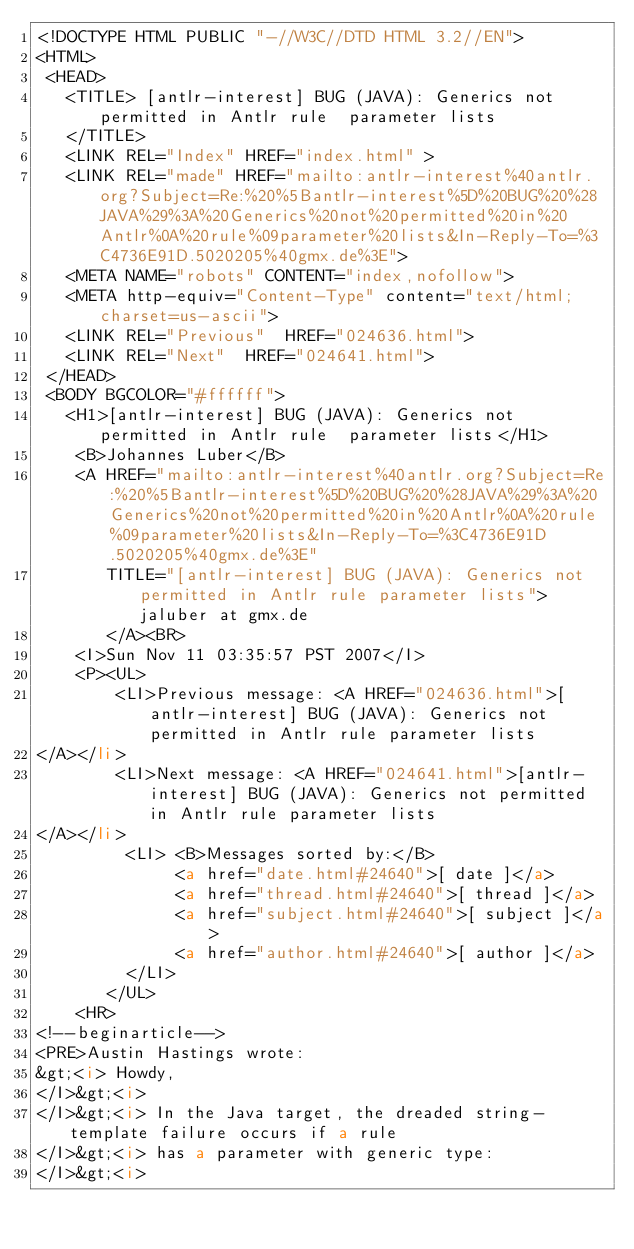<code> <loc_0><loc_0><loc_500><loc_500><_HTML_><!DOCTYPE HTML PUBLIC "-//W3C//DTD HTML 3.2//EN">
<HTML>
 <HEAD>
   <TITLE> [antlr-interest] BUG (JAVA): Generics not permitted in Antlr rule	parameter lists
   </TITLE>
   <LINK REL="Index" HREF="index.html" >
   <LINK REL="made" HREF="mailto:antlr-interest%40antlr.org?Subject=Re:%20%5Bantlr-interest%5D%20BUG%20%28JAVA%29%3A%20Generics%20not%20permitted%20in%20Antlr%0A%20rule%09parameter%20lists&In-Reply-To=%3C4736E91D.5020205%40gmx.de%3E">
   <META NAME="robots" CONTENT="index,nofollow">
   <META http-equiv="Content-Type" content="text/html; charset=us-ascii">
   <LINK REL="Previous"  HREF="024636.html">
   <LINK REL="Next"  HREF="024641.html">
 </HEAD>
 <BODY BGCOLOR="#ffffff">
   <H1>[antlr-interest] BUG (JAVA): Generics not permitted in Antlr rule	parameter lists</H1>
    <B>Johannes Luber</B> 
    <A HREF="mailto:antlr-interest%40antlr.org?Subject=Re:%20%5Bantlr-interest%5D%20BUG%20%28JAVA%29%3A%20Generics%20not%20permitted%20in%20Antlr%0A%20rule%09parameter%20lists&In-Reply-To=%3C4736E91D.5020205%40gmx.de%3E"
       TITLE="[antlr-interest] BUG (JAVA): Generics not permitted in Antlr rule	parameter lists">jaluber at gmx.de
       </A><BR>
    <I>Sun Nov 11 03:35:57 PST 2007</I>
    <P><UL>
        <LI>Previous message: <A HREF="024636.html">[antlr-interest] BUG (JAVA): Generics not permitted in Antlr rule	parameter lists
</A></li>
        <LI>Next message: <A HREF="024641.html">[antlr-interest] BUG (JAVA): Generics not permitted in Antlr rule	parameter lists
</A></li>
         <LI> <B>Messages sorted by:</B> 
              <a href="date.html#24640">[ date ]</a>
              <a href="thread.html#24640">[ thread ]</a>
              <a href="subject.html#24640">[ subject ]</a>
              <a href="author.html#24640">[ author ]</a>
         </LI>
       </UL>
    <HR>  
<!--beginarticle-->
<PRE>Austin Hastings wrote:
&gt;<i> Howdy,
</I>&gt;<i> 
</I>&gt;<i> In the Java target, the dreaded string-template failure occurs if a rule
</I>&gt;<i> has a parameter with generic type:
</I>&gt;<i> </code> 